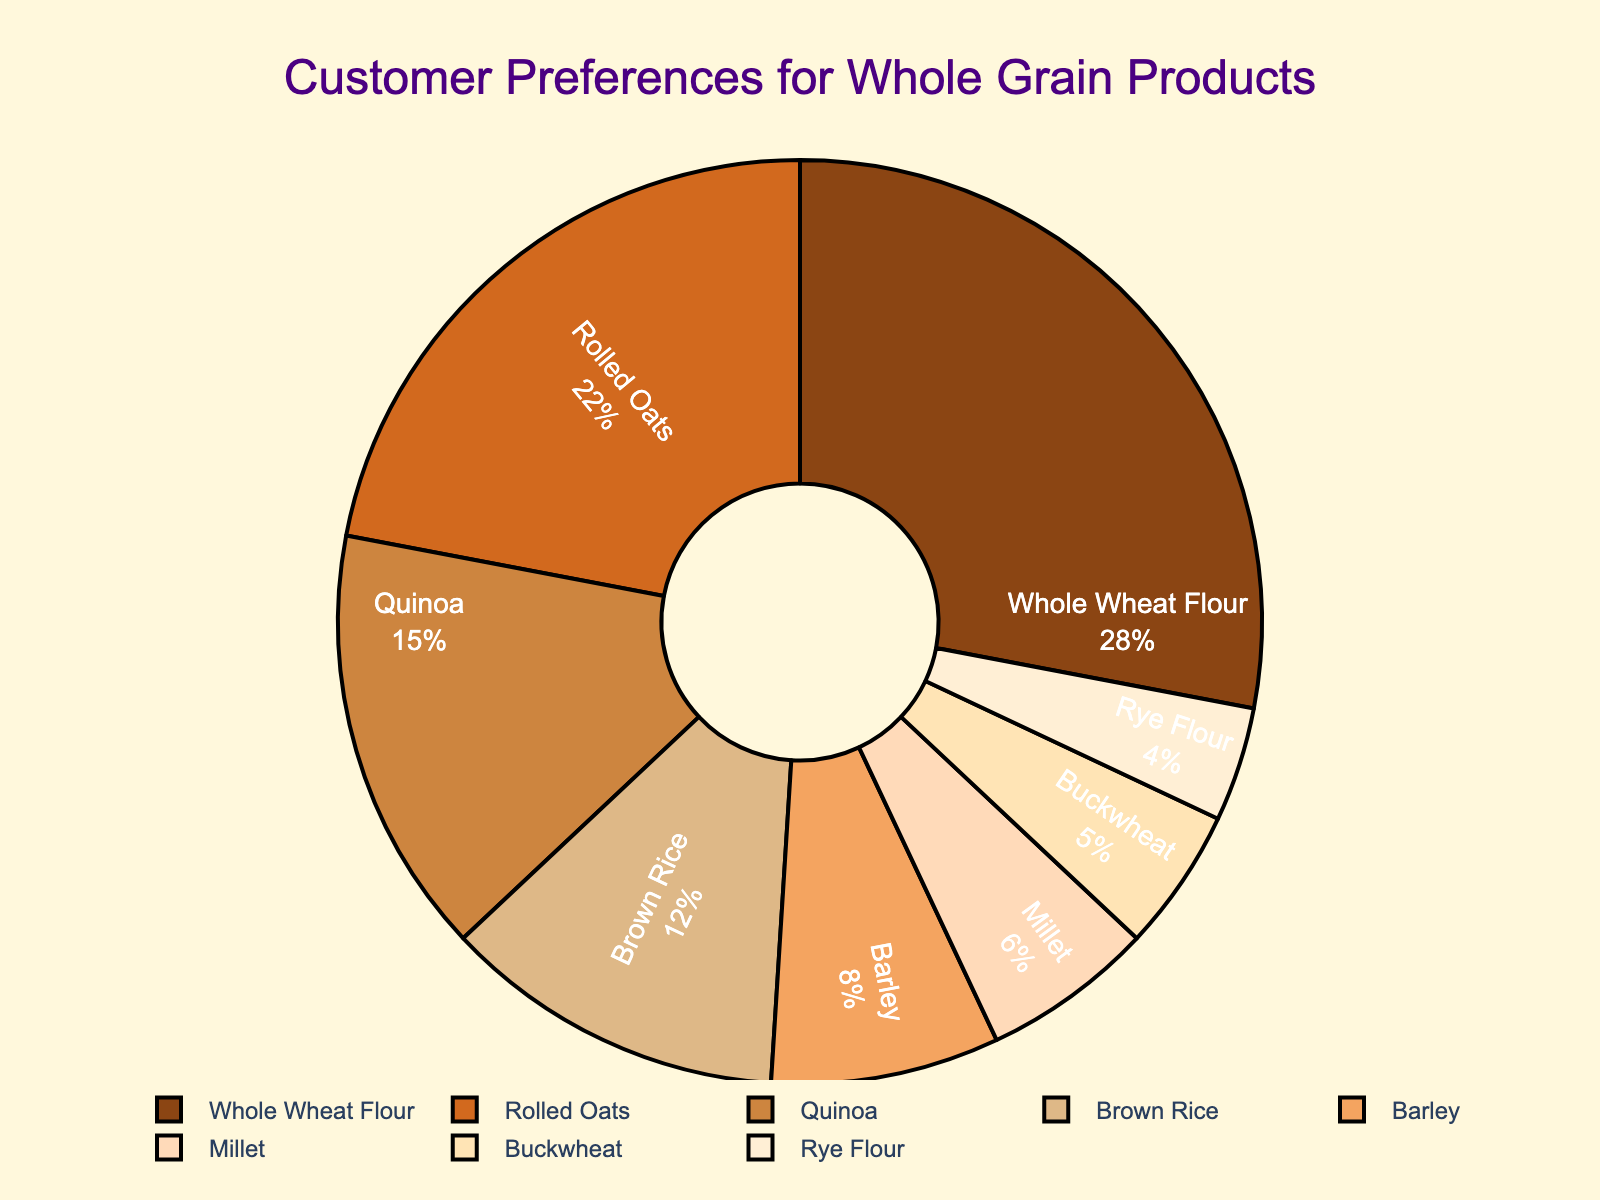Which whole grain product has the highest percentage of customer preference? The slice labeled "Whole Wheat Flour" has the highest percentage at 28%, indicating it’s the most preferred product.
Answer: Whole Wheat Flour What is the combined customer preference percentage for Quinoa, Brown Rice, and Barley? Add the percentages for Quinoa (15%), Brown Rice (12%), and Barley (8%): 15 + 12 + 8 = 35%.
Answer: 35% Which products have a combined customer preference percentage of more than 30%? Whole Wheat Flour (28%) and Rolled Oats (22%) combined equal 50%, which is more than 30%.
Answer: Whole Wheat Flour and Rolled Oats Which product has a lower customer preference, Millet or Buckwheat? Millet's slice is labeled with 6% while Buckwheat's slice is labeled with 5%, so Buckwheat has a lower preference.
Answer: Buckwheat What is the difference in customer preference percentage between Rolled Oats and Rye Flour? The percentage for Rolled Oats is 22% and for Rye Flour is 4%. The difference is 22 - 4 = 18%.
Answer: 18% Which product's slice is the smallest in the pie chart? The slice labeled "Rye Flour" has the smallest percentage at 4%.
Answer: Rye Flour How many products have a preference percentage greater than 10%? There are four products with more than 10%: Whole Wheat Flour (28%), Rolled Oats (22%), Quinoa (15%), and Brown Rice (12%).
Answer: 4 Compare the customer preference for Quinoa and Barley. Which is more preferred? Quinoa’s percentage is 15%, while Barley’s is 8%. Quinoa has a higher preference.
Answer: Quinoa What is the total percentage of customer preference for products other than Whole Wheat Flour and Rolled Oats? Sum the percentages for all other products (Quinoa, Brown Rice, Barley, Millet, Buckwheat, and Rye Flour): 15 + 12 + 8 + 6 + 5 + 4 = 50%.
Answer: 50% What is the average customer preference percentage for Buckwheat and Rye Flour? Add the percentages for Buckwheat (5%) and Rye Flour (4%) and divide by 2: (5 + 4) / 2 = 4.5%.
Answer: 4.5% 